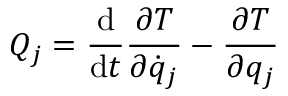<formula> <loc_0><loc_0><loc_500><loc_500>Q _ { j } = { \frac { d } { d t } } { \frac { \partial T } { \partial { \dot { q } } _ { j } } } - { \frac { \partial T } { \partial q _ { j } } }</formula> 